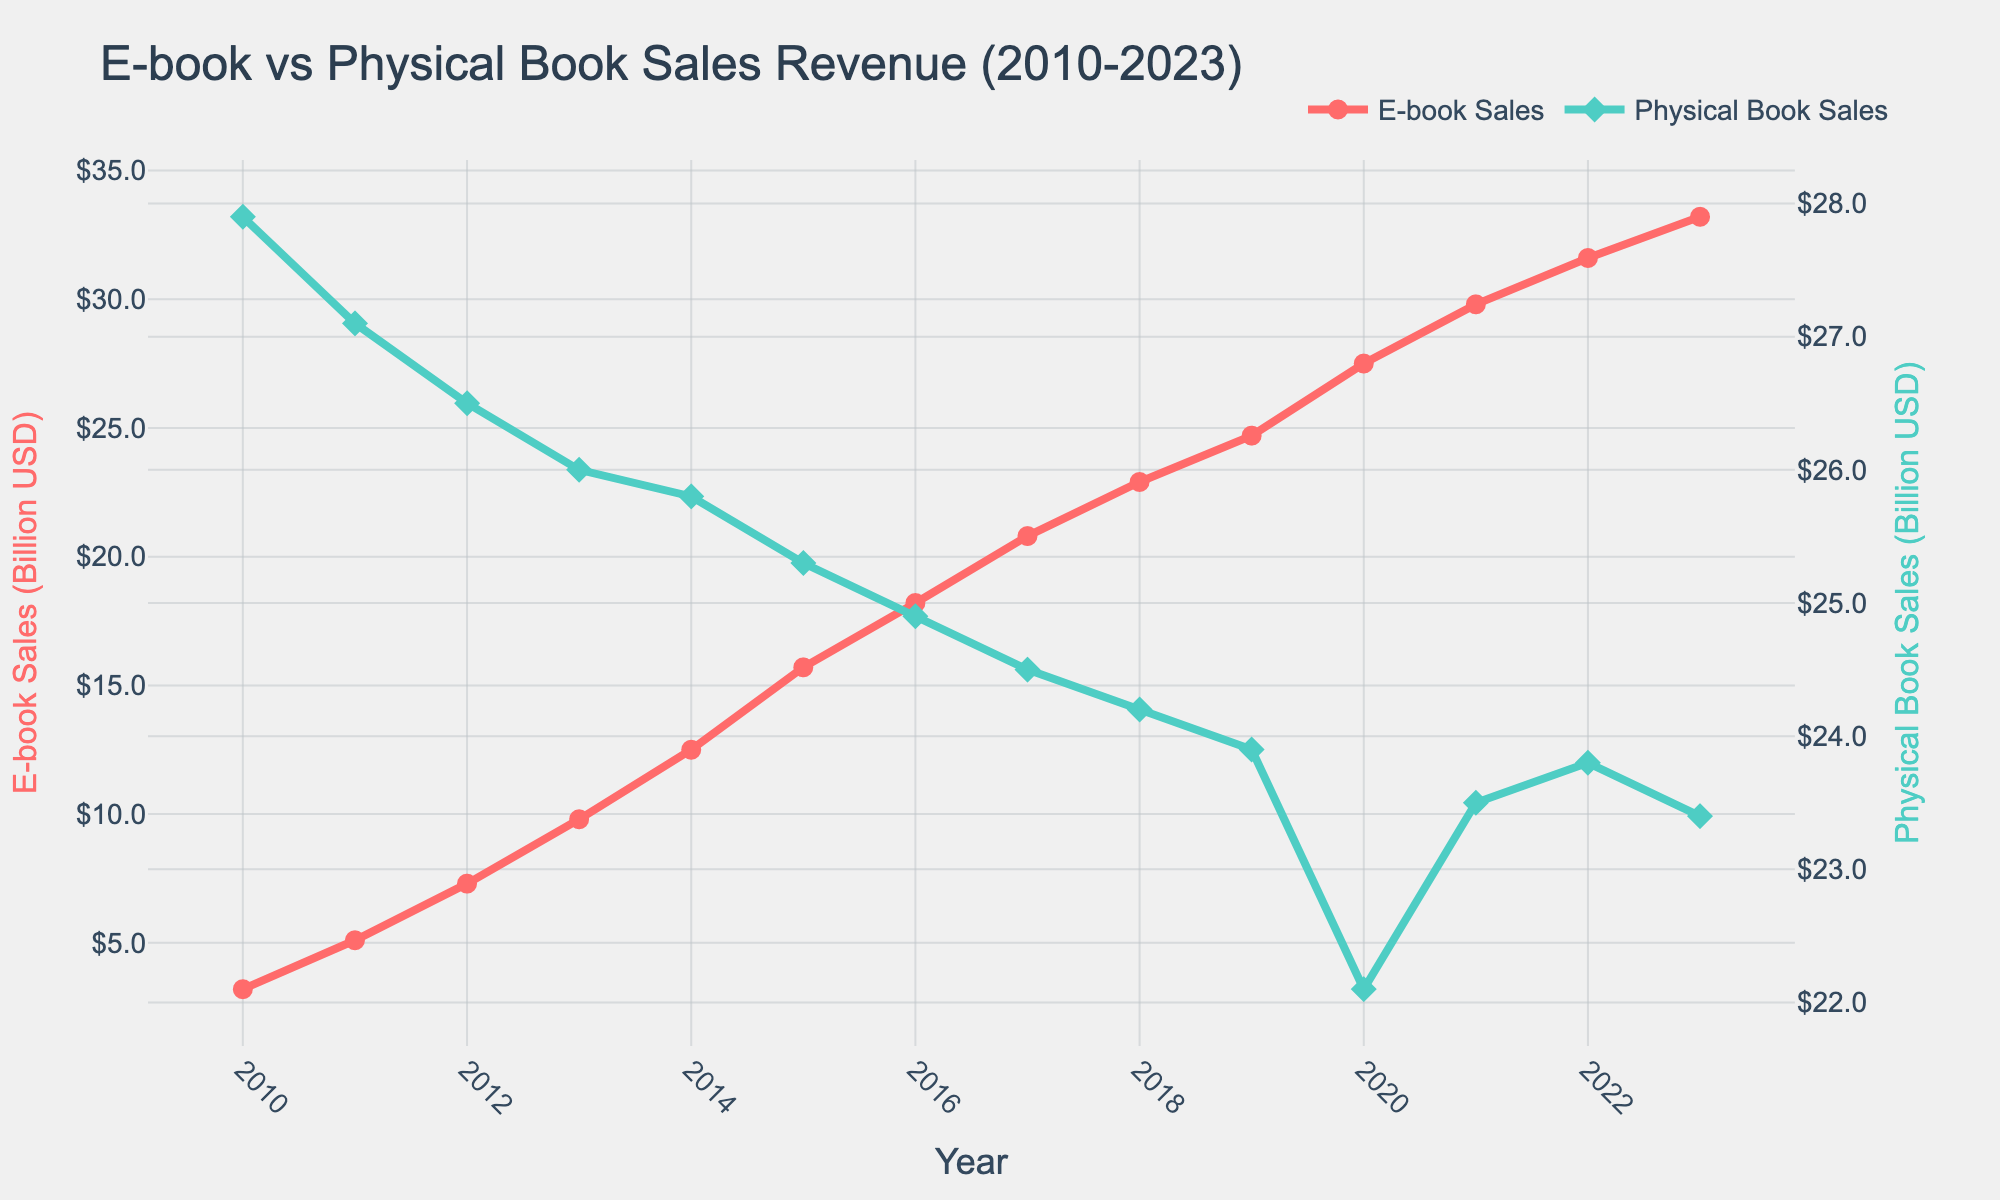What's the overall trend for e-book sales from 2010 to 2023? E-book sales revenue shows a consistent increase over the years, starting from 3.2 billion USD in 2010 and reaching 33.2 billion USD in 2023.
Answer: Increasing What's the difference in revenue between e-books and physical books in 2023? In 2023, e-book sales revenue is 33.2 billion USD, and physical book sales revenue is 23.4 billion USD. The difference is 33.2 - 23.4 = 9.8 billion USD.
Answer: 9.8 billion USD In which year did e-book sales revenue surpass physical book sales revenue? Looking at the figure, e-book sales revenue surpasses physical book sales revenue starting from 2019, where e-book sales revenue is 24.7 billion USD, compared to physical book sales at 23.9 billion USD.
Answer: 2019 Which year had the highest year-on-year growth for e-book sales? To find the year with the highest year-on-year growth, we need to calculate the differences year to year: 
2011: 5.1 - 3.2 = 1.9; 2012: 7.3 - 5.1 = 2.2; ... 2023: 33.2 - 31.6 = 1.6. 
The largest increase is from 2014 to 2015, which is 15.7 - 12.5 = 3.2 billion USD.
Answer: 2015 How has physical book sales revenue changed from 2010 to 2023? Physical book sales revenue starts at 27.9 billion USD in 2010 and fluctuates slightly over time, reaching 23.4 billion USD in 2023.
Answer: Fluctuates slightly, but overall decreasing What's the average annual revenue for e-books from 2010 to 2023? Sum the e-book revenue values from each year and divide by the number of years (14): 
(3.2 + 5.1 + 7.3 + 9.8 + 12.5 + 15.7 + 18.2 + 20.8 + 22.9 + 24.7 + 27.5 + 29.8 + 31.6 + 33.2) / 14 = 19.225 billion USD.
Answer: 19.225 billion USD Between 2010 and 2013, which type of book sales had lower revenue each year? From 2010 to 2013, physical book sales revenue is consistently higher than e-book sales revenue each year, as shown by the higher position of the green line on the chart compared to the red line.
Answer: E-books What was the revenue for physical book sales in 2019? Referring to the chart, physical book sales revenue in 2019 is shown by the green line's value in 2019, which is 23.9 billion USD.
Answer: 23.9 billion USD What year had the lowest revenue for physical book sales? The lowest point on the green line representing physical book sales is in 2020, with revenue at 22.1 billion USD.
Answer: 2020 Which type of book sales showed a more stable trend over the years? By examining the lines, the green line (physical book sales) shows less fluctuation compared to the red line (e-book sales), which indicates a more stable trend.
Answer: Physical book sales 